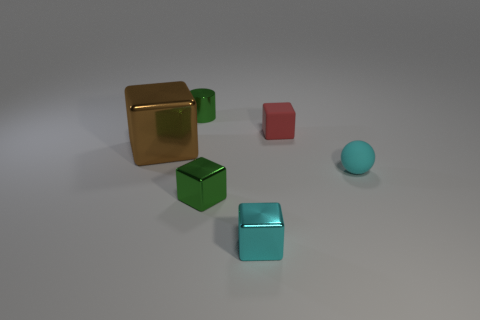What shape is the object that is the same color as the small cylinder?
Provide a short and direct response. Cube. Are there fewer small metal cubes behind the tiny red cube than metallic cubes that are in front of the large brown shiny block?
Provide a short and direct response. Yes. There is a cyan block that is in front of the ball; is it the same size as the tiny matte ball?
Keep it short and to the point. Yes. There is a tiny green object in front of the cylinder; what shape is it?
Keep it short and to the point. Cube. Are there more tiny cyan shiny blocks than tiny green metallic objects?
Ensure brevity in your answer.  No. Do the small rubber block that is on the left side of the cyan sphere and the big metal block have the same color?
Offer a very short reply. No. What number of objects are either tiny shiny cylinders behind the red cube or things that are right of the cyan metal block?
Your answer should be very brief. 3. What number of small objects are both behind the brown metal block and to the right of the rubber block?
Provide a succinct answer. 0. Does the ball have the same material as the tiny red block?
Provide a succinct answer. Yes. What is the shape of the small green object that is to the left of the green metal object in front of the metal block on the left side of the green cylinder?
Give a very brief answer. Cylinder. 